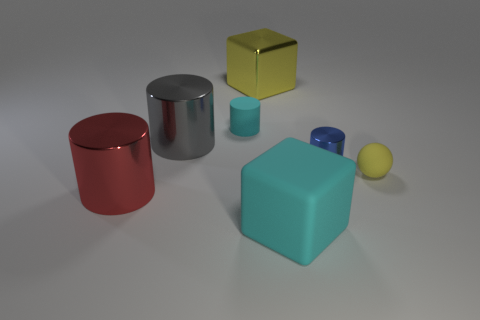Subtract all cylinders. How many objects are left? 3 Add 1 large gray metallic cylinders. How many objects exist? 8 Subtract all blue metallic cylinders. How many cylinders are left? 3 Subtract 0 brown blocks. How many objects are left? 7 Subtract 1 spheres. How many spheres are left? 0 Subtract all yellow blocks. Subtract all red spheres. How many blocks are left? 1 Subtract all blue cubes. How many blue cylinders are left? 1 Subtract all yellow balls. Subtract all blue cylinders. How many objects are left? 5 Add 7 big rubber cubes. How many big rubber cubes are left? 8 Add 3 small cyan rubber cylinders. How many small cyan rubber cylinders exist? 4 